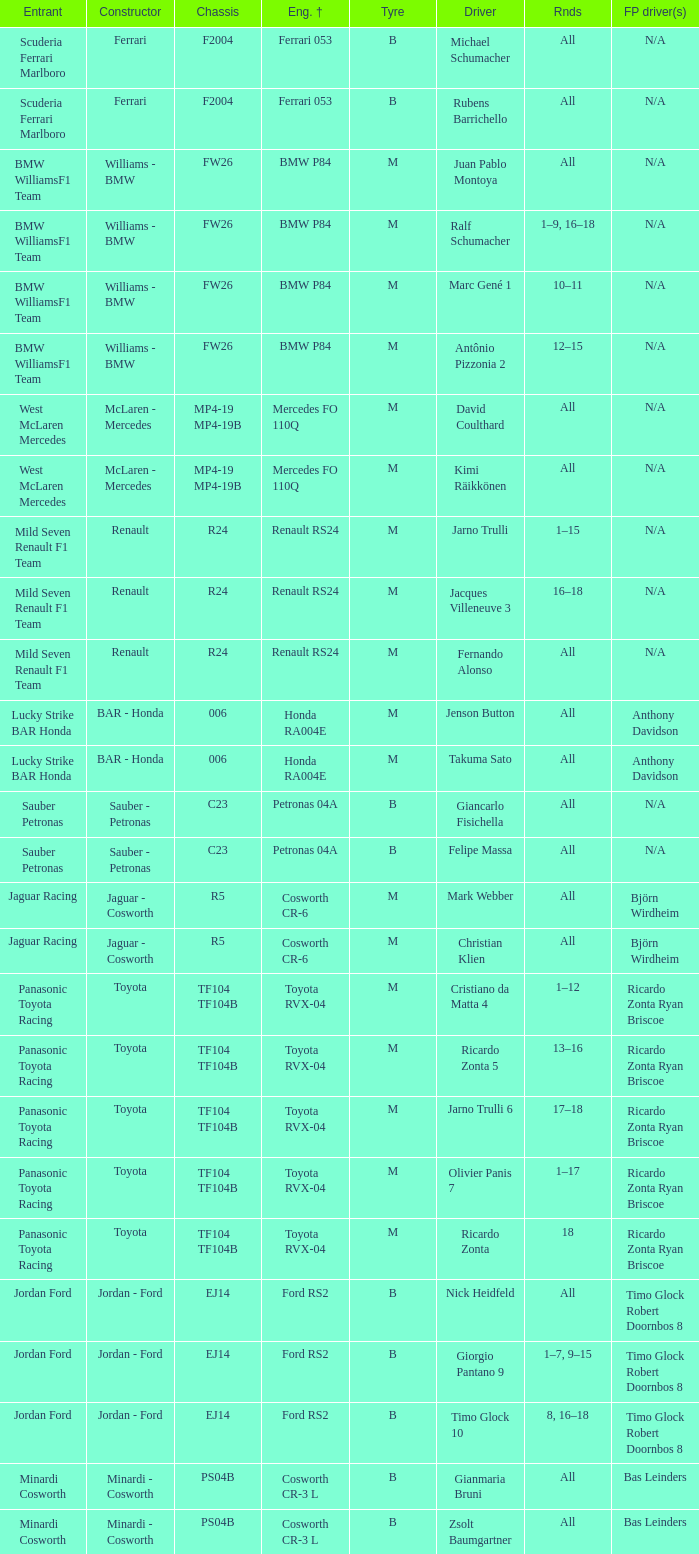What are the rounds for the B tyres and Ferrari 053 engine +? All, All. 